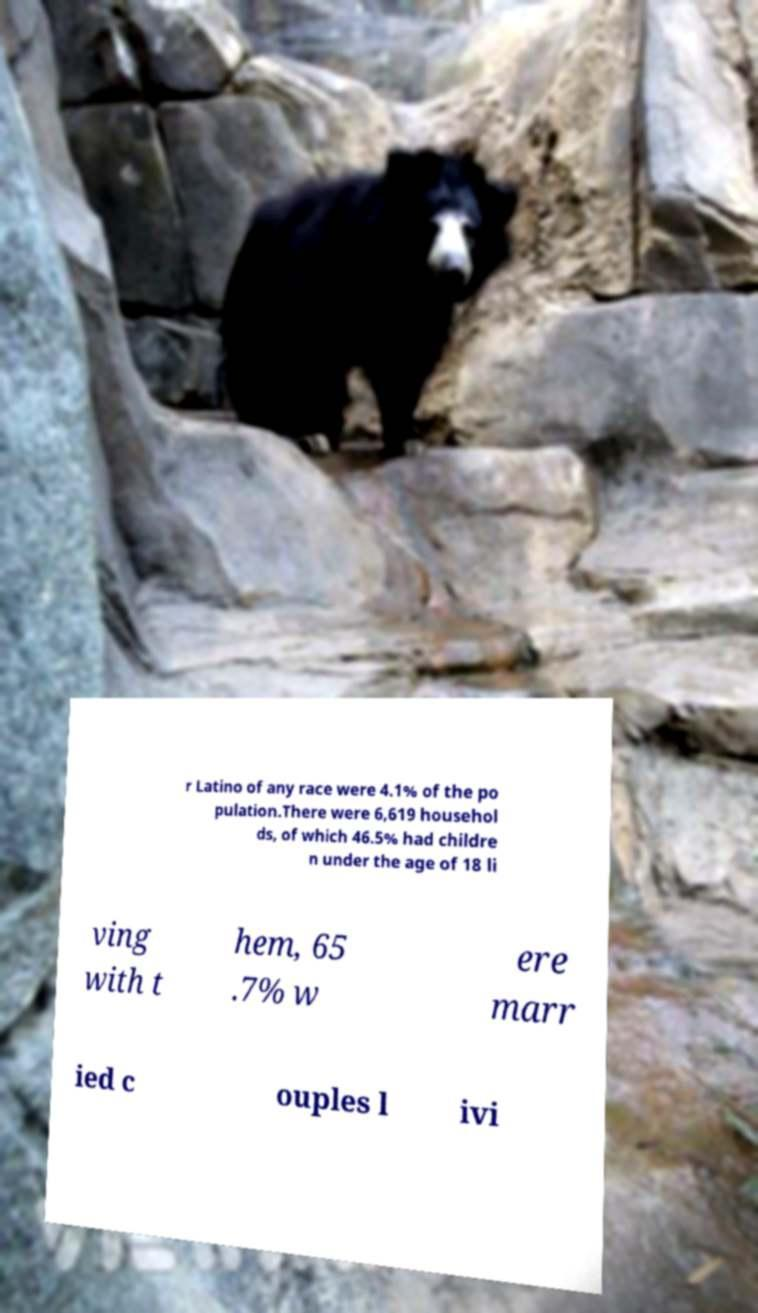Can you read and provide the text displayed in the image?This photo seems to have some interesting text. Can you extract and type it out for me? r Latino of any race were 4.1% of the po pulation.There were 6,619 househol ds, of which 46.5% had childre n under the age of 18 li ving with t hem, 65 .7% w ere marr ied c ouples l ivi 